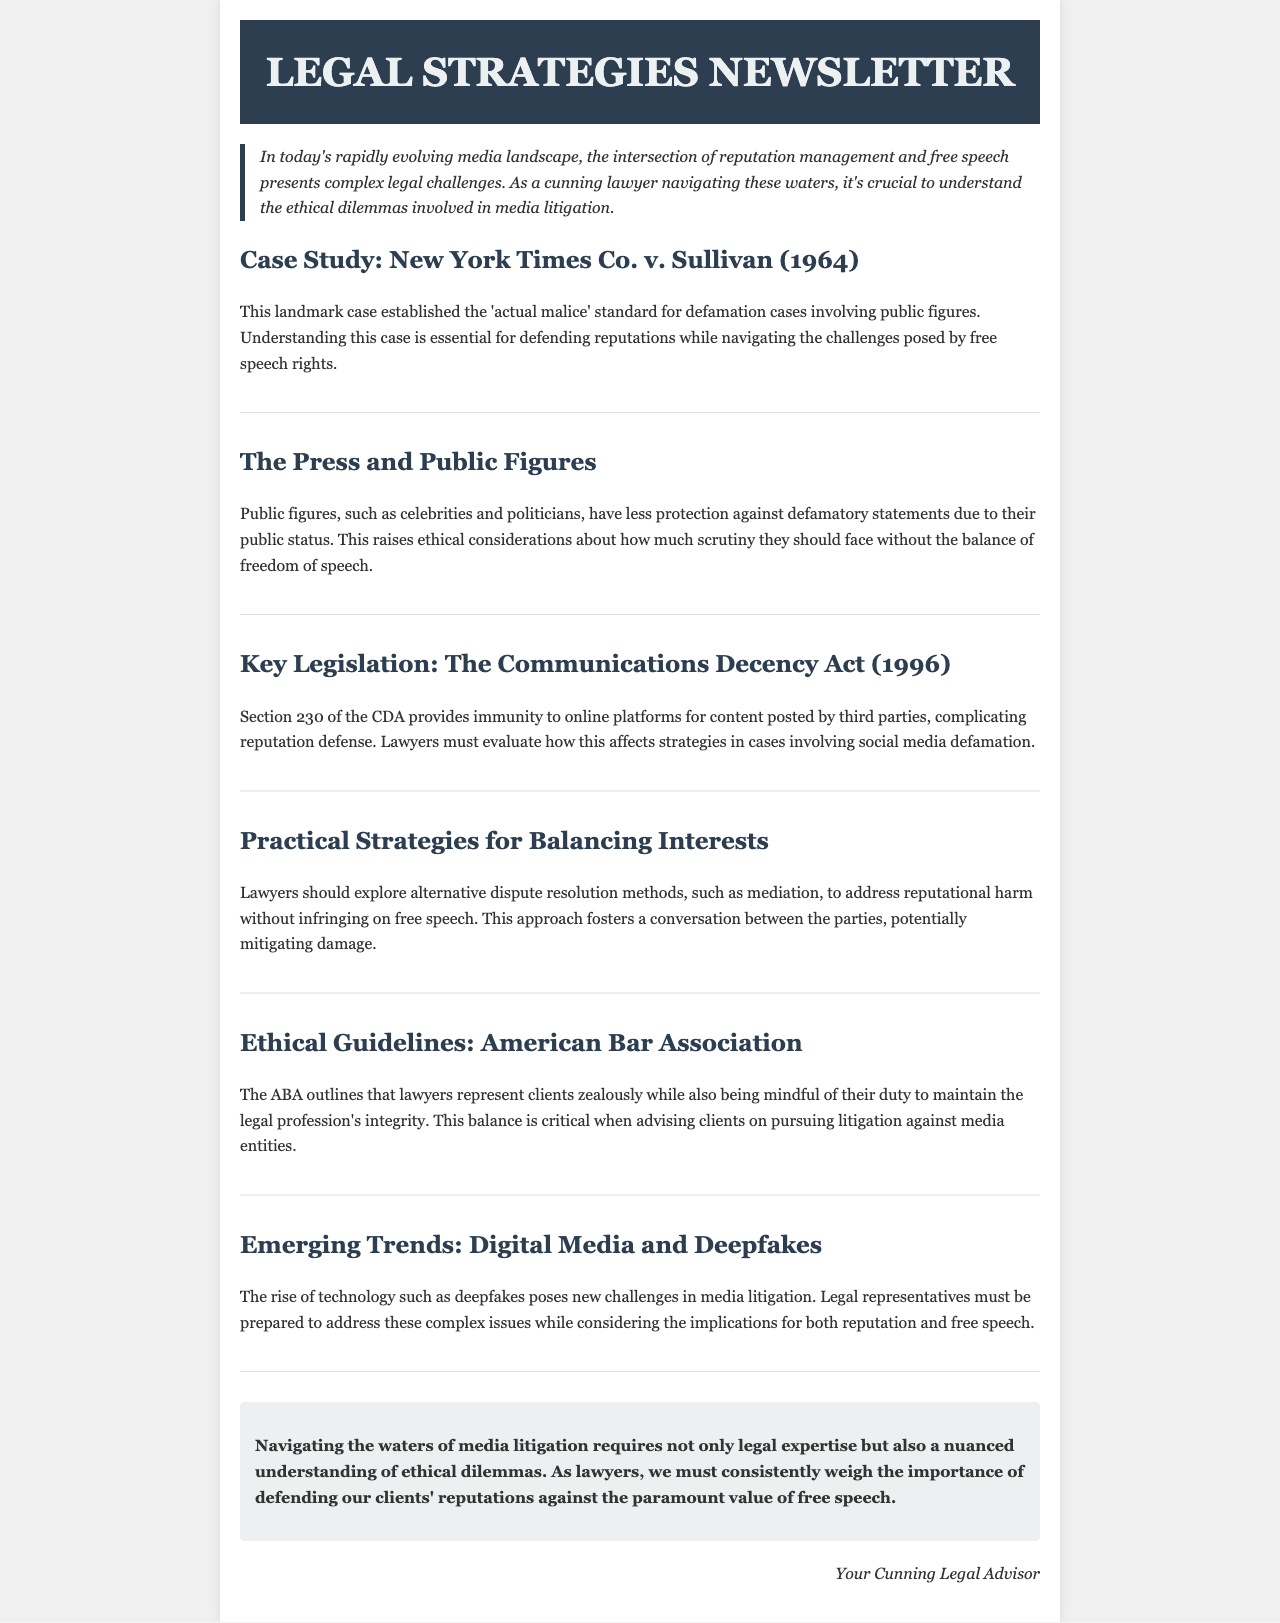What landmark case established the 'actual malice' standard? The document describes the New York Times Co. v. Sullivan (1964) case as establishing this standard.
Answer: New York Times Co. v. Sullivan (1964) What does Section 230 of the Communications Decency Act provide? The document states that Section 230 provides immunity to online platforms for content posted by third parties.
Answer: Immunity What is a recommended alternative dispute resolution method mentioned? The document suggests mediation as a method to address reputational harm without infringing on free speech.
Answer: Mediation Which organization’s guidelines are referenced for ethical guidelines? The document mentions the American Bar Association in relation to ethical guidelines for lawyers.
Answer: American Bar Association What emerging technology poses new challenges in media litigation? The document discusses deepfakes as a significant emerging technology that complicates media litigation.
Answer: Deepfakes How should lawyers maintain the integrity of the legal profession, according to the document? The document outlines that lawyers should balance zealous representation with the integrity of the legal profession.
Answer: Balance What is the primary ethical dilemma faced by lawyers in media litigation? The document describes the challenge of weighing the defense of reputations against the value of free speech.
Answer: Balancing reputation defense and free speech rights What is a key consideration when dealing with public figures in media litigation? The document indicates that public figures have less protection against defamatory statements due to their public status.
Answer: Less protection What does the conclusion emphasize as necessary for navigating media litigation? The conclusion stresses the importance of legal expertise and understanding ethical dilemmas in media litigation.
Answer: Legal expertise and understanding ethical dilemmas 